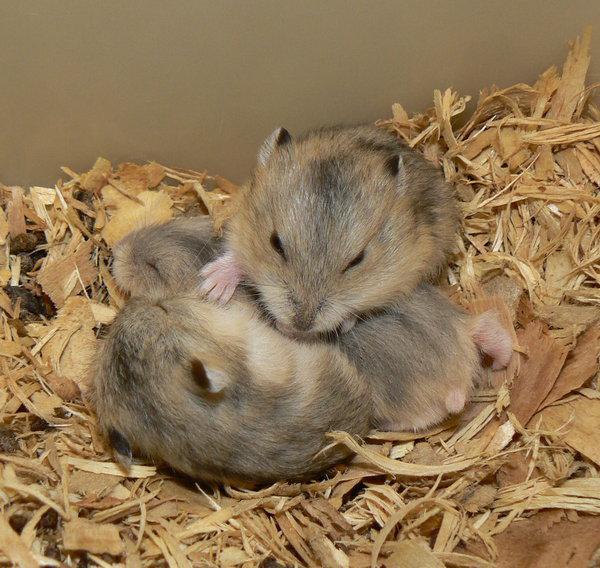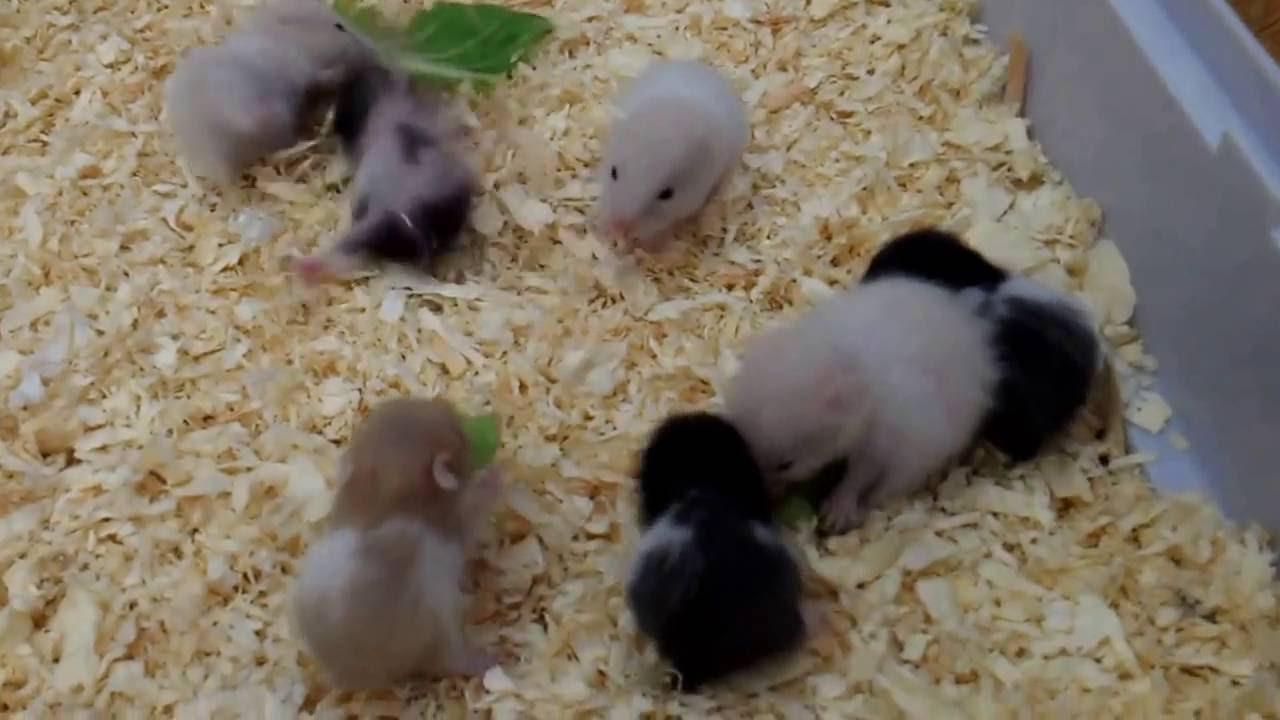The first image is the image on the left, the second image is the image on the right. Examine the images to the left and right. Is the description "There are more hamsters in the right image than in the left image." accurate? Answer yes or no. Yes. The first image is the image on the left, the second image is the image on the right. Evaluate the accuracy of this statement regarding the images: "The left image contains only non-newborn mouse-like pets, and the right image shows all mouse-like pets on shredded bedding.". Is it true? Answer yes or no. Yes. 